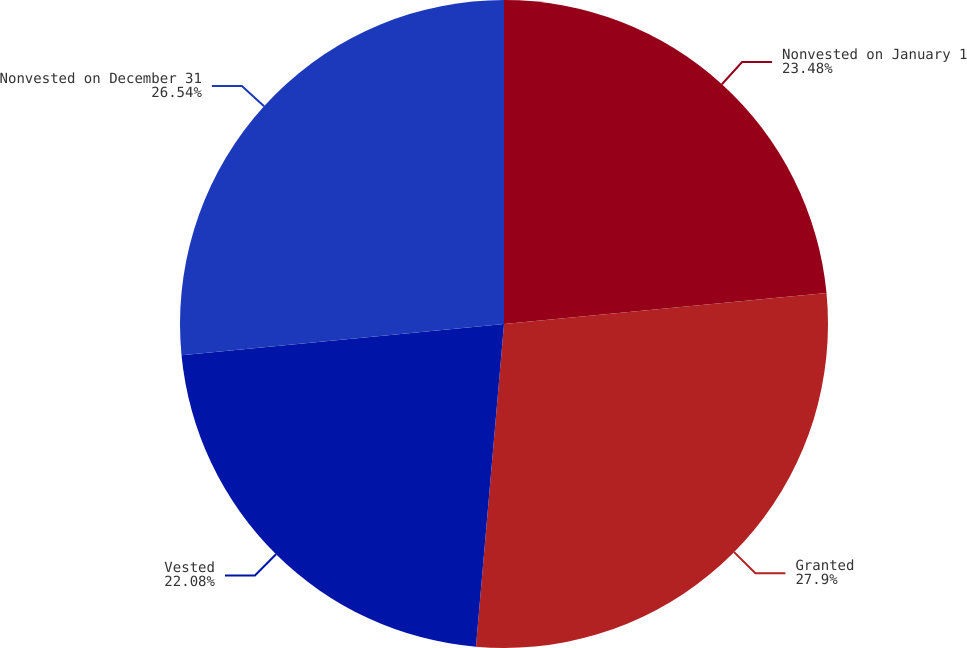Convert chart. <chart><loc_0><loc_0><loc_500><loc_500><pie_chart><fcel>Nonvested on January 1<fcel>Granted<fcel>Vested<fcel>Nonvested on December 31<nl><fcel>23.48%<fcel>27.9%<fcel>22.08%<fcel>26.54%<nl></chart> 